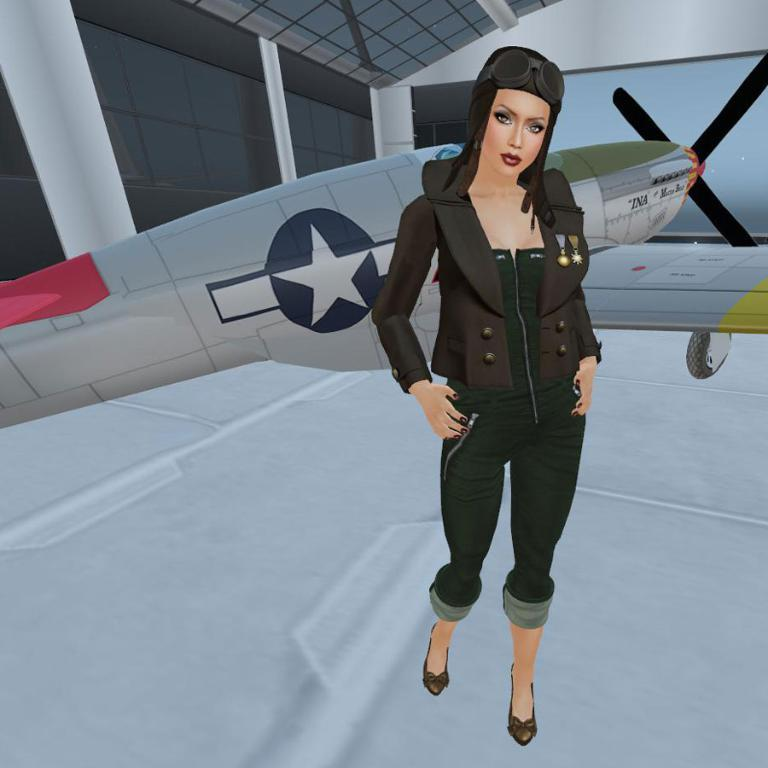What is the main subject of the image? There is a woman standing in the image. What is the woman standing on? The woman is standing on the floor. What can be seen in the background of the image? There is an aircraft and a wall in the background of the image. Are there any objects made of glass in the background? Yes, there are glass objects in the background of the image. What type of chin is visible on the woman in the image? There is no chin visible on the woman in the image, as the image only shows her from the waist up. 